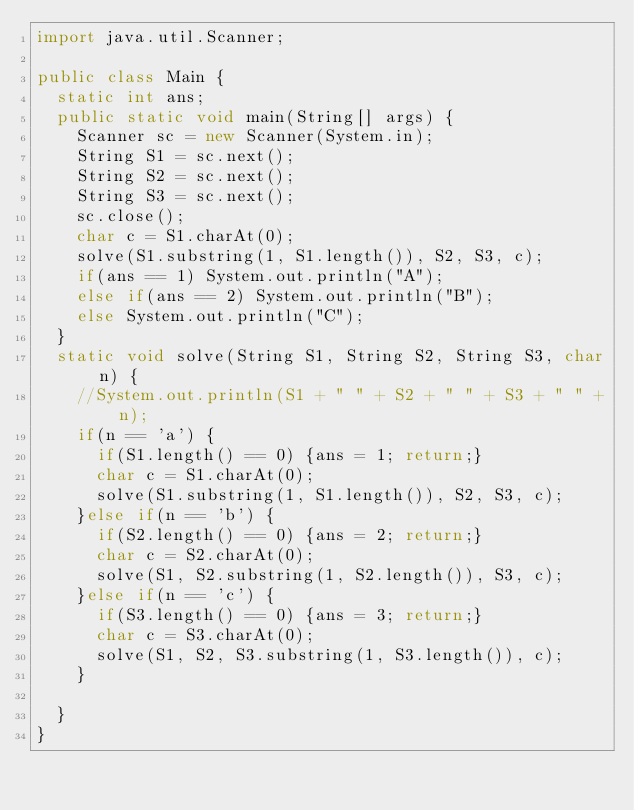<code> <loc_0><loc_0><loc_500><loc_500><_Java_>import java.util.Scanner;

public class Main {
	static int ans;
	public static void main(String[] args) {
		Scanner sc = new Scanner(System.in);
		String S1 = sc.next();
		String S2 = sc.next();
		String S3 = sc.next();
		sc.close();
		char c = S1.charAt(0);
		solve(S1.substring(1, S1.length()), S2, S3, c);
		if(ans == 1) System.out.println("A");
		else if(ans == 2) System.out.println("B");
		else System.out.println("C");
	}
	static void solve(String S1, String S2, String S3, char n) {
		//System.out.println(S1 + " " + S2 + " " + S3 + " " + n);
		if(n == 'a') {
			if(S1.length() == 0) {ans = 1; return;}
			char c = S1.charAt(0);
			solve(S1.substring(1, S1.length()), S2, S3, c);
		}else if(n == 'b') {
			if(S2.length() == 0) {ans = 2; return;}
			char c = S2.charAt(0);
			solve(S1, S2.substring(1, S2.length()), S3, c);
		}else if(n == 'c') {
			if(S3.length() == 0) {ans = 3; return;}
			char c = S3.charAt(0);
			solve(S1, S2, S3.substring(1, S3.length()), c);
		}

	}
}</code> 